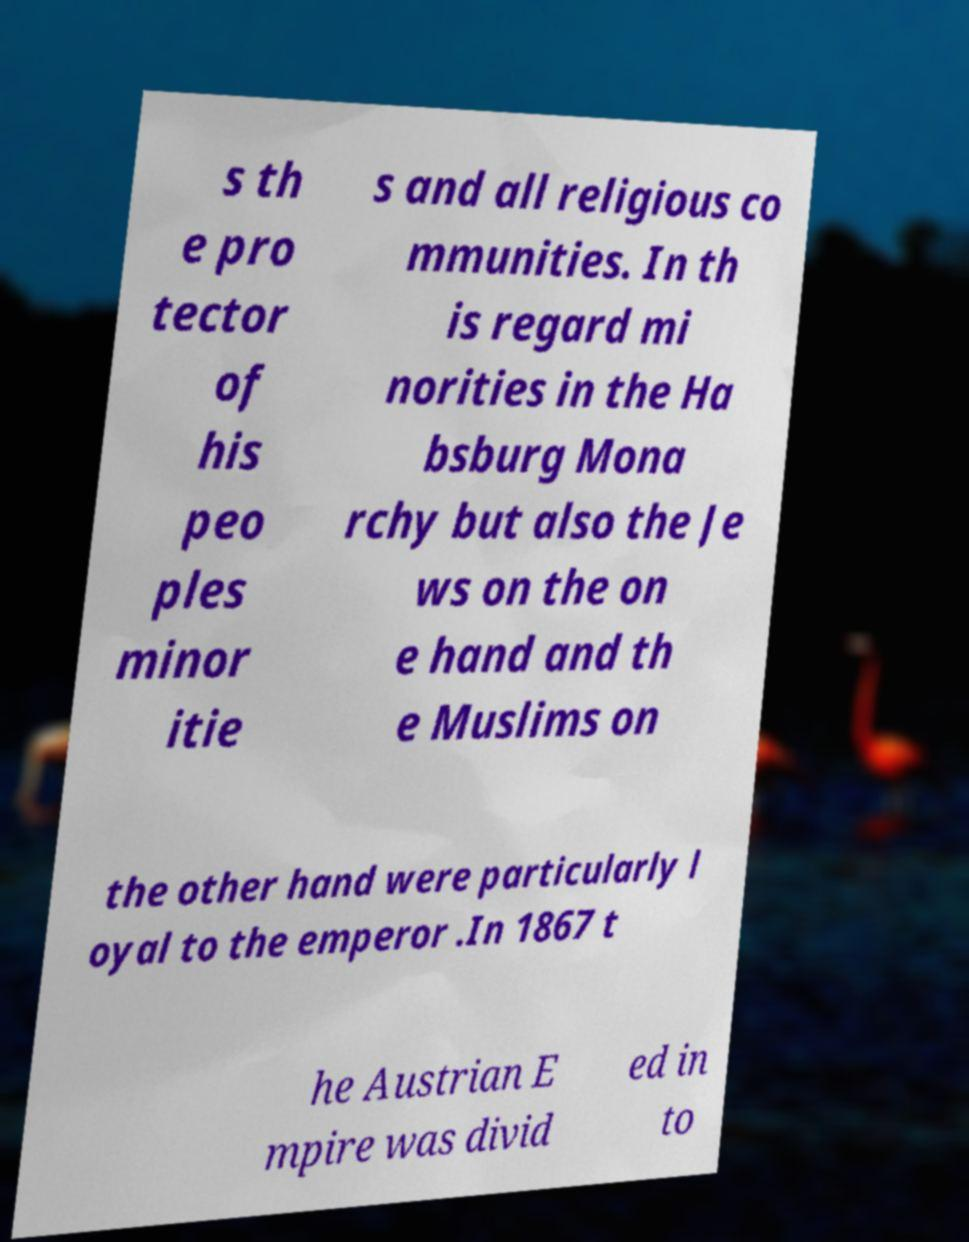Please read and relay the text visible in this image. What does it say? s th e pro tector of his peo ples minor itie s and all religious co mmunities. In th is regard mi norities in the Ha bsburg Mona rchy but also the Je ws on the on e hand and th e Muslims on the other hand were particularly l oyal to the emperor .In 1867 t he Austrian E mpire was divid ed in to 